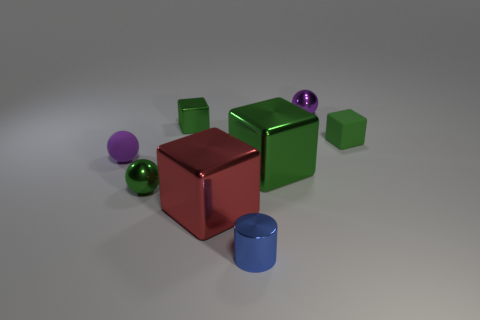Subtract all green cubes. How many were subtracted if there are1green cubes left? 2 Subtract all cyan cylinders. How many green cubes are left? 3 Subtract 1 blocks. How many blocks are left? 3 Add 2 big green things. How many objects exist? 10 Subtract all balls. How many objects are left? 5 Subtract 1 green balls. How many objects are left? 7 Subtract all large red shiny blocks. Subtract all small green matte balls. How many objects are left? 7 Add 3 small green blocks. How many small green blocks are left? 5 Add 7 big brown cubes. How many big brown cubes exist? 7 